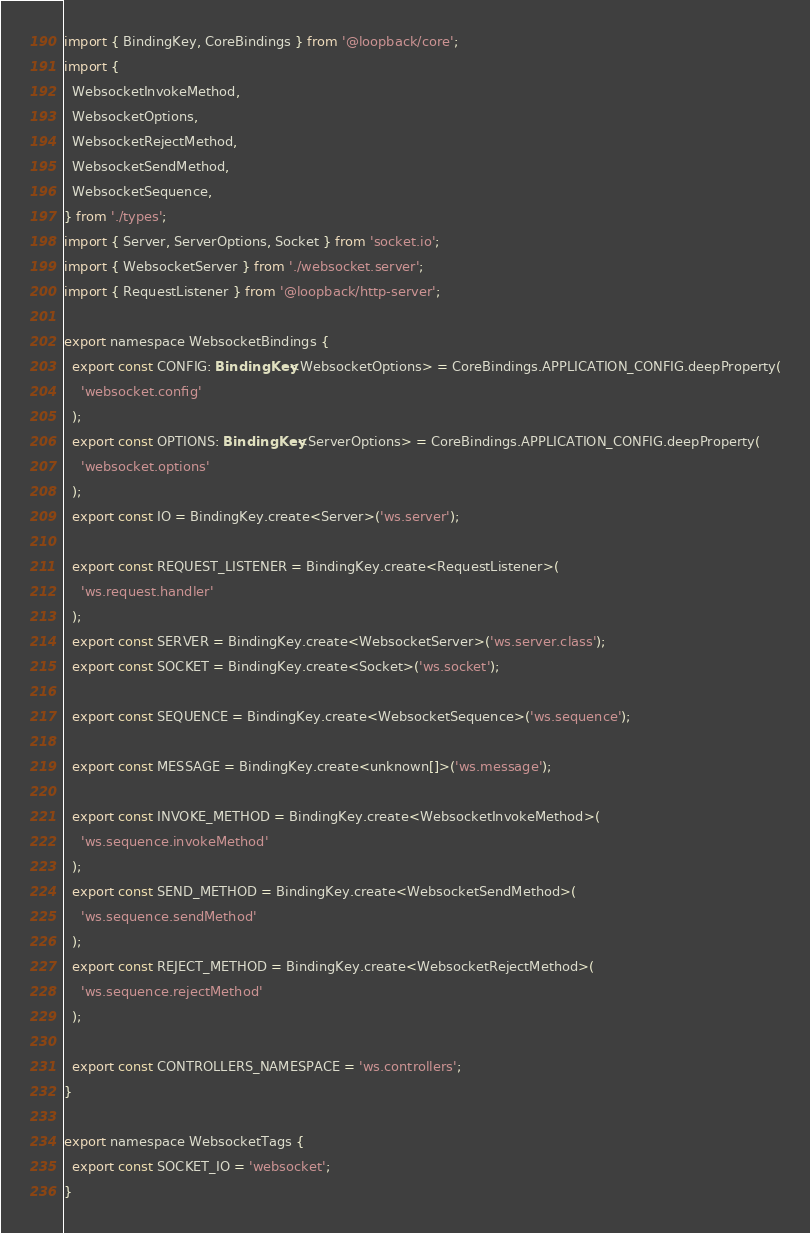Convert code to text. <code><loc_0><loc_0><loc_500><loc_500><_TypeScript_>import { BindingKey, CoreBindings } from '@loopback/core';
import {
  WebsocketInvokeMethod,
  WebsocketOptions,
  WebsocketRejectMethod,
  WebsocketSendMethod,
  WebsocketSequence,
} from './types';
import { Server, ServerOptions, Socket } from 'socket.io';
import { WebsocketServer } from './websocket.server';
import { RequestListener } from '@loopback/http-server';

export namespace WebsocketBindings {
  export const CONFIG: BindingKey<WebsocketOptions> = CoreBindings.APPLICATION_CONFIG.deepProperty(
    'websocket.config'
  );
  export const OPTIONS: BindingKey<ServerOptions> = CoreBindings.APPLICATION_CONFIG.deepProperty(
    'websocket.options'
  );
  export const IO = BindingKey.create<Server>('ws.server');

  export const REQUEST_LISTENER = BindingKey.create<RequestListener>(
    'ws.request.handler'
  );
  export const SERVER = BindingKey.create<WebsocketServer>('ws.server.class');
  export const SOCKET = BindingKey.create<Socket>('ws.socket');

  export const SEQUENCE = BindingKey.create<WebsocketSequence>('ws.sequence');

  export const MESSAGE = BindingKey.create<unknown[]>('ws.message');

  export const INVOKE_METHOD = BindingKey.create<WebsocketInvokeMethod>(
    'ws.sequence.invokeMethod'
  );
  export const SEND_METHOD = BindingKey.create<WebsocketSendMethod>(
    'ws.sequence.sendMethod'
  );
  export const REJECT_METHOD = BindingKey.create<WebsocketRejectMethod>(
    'ws.sequence.rejectMethod'
  );

  export const CONTROLLERS_NAMESPACE = 'ws.controllers';
}

export namespace WebsocketTags {
  export const SOCKET_IO = 'websocket';
}
</code> 